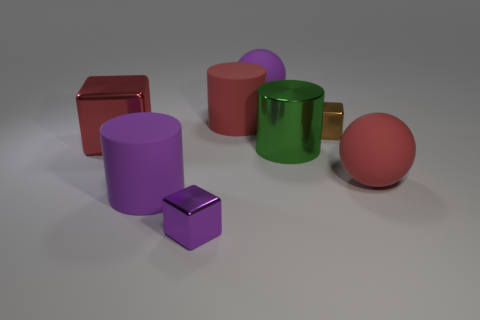Add 1 red metallic objects. How many objects exist? 9 Subtract all blocks. How many objects are left? 5 Subtract all metallic cylinders. Subtract all red metallic blocks. How many objects are left? 6 Add 1 green things. How many green things are left? 2 Add 8 yellow cubes. How many yellow cubes exist? 8 Subtract 0 yellow cylinders. How many objects are left? 8 